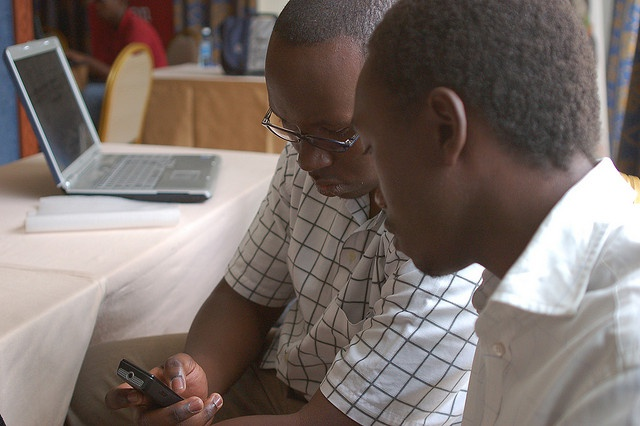Describe the objects in this image and their specific colors. I can see people in blue, black, gray, and white tones, people in blue, gray, black, maroon, and darkgray tones, dining table in blue, lightgray, and darkgray tones, laptop in blue, darkgray, gray, and black tones, and dining table in blue, gray, brown, and darkgray tones in this image. 